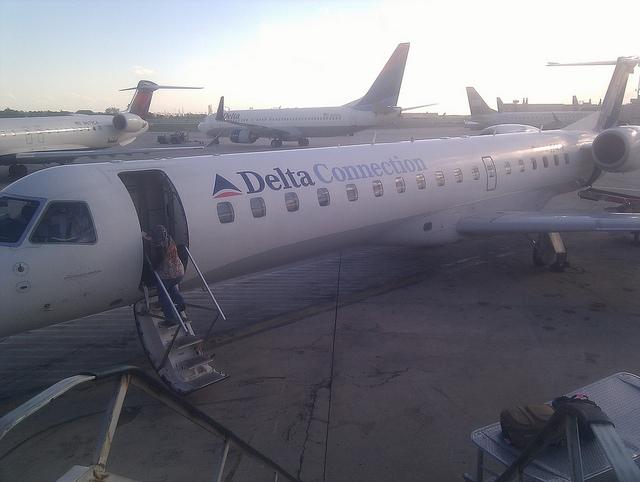What is the brand of plane?
Be succinct. Delta. Who uses this plane for travel?
Quick response, please. People. How many passenger seats are on this airplane?
Keep it brief. 36. Is the plane ready for takeoff?
Keep it brief. No. What is the main color of this plane?
Give a very brief answer. White. 